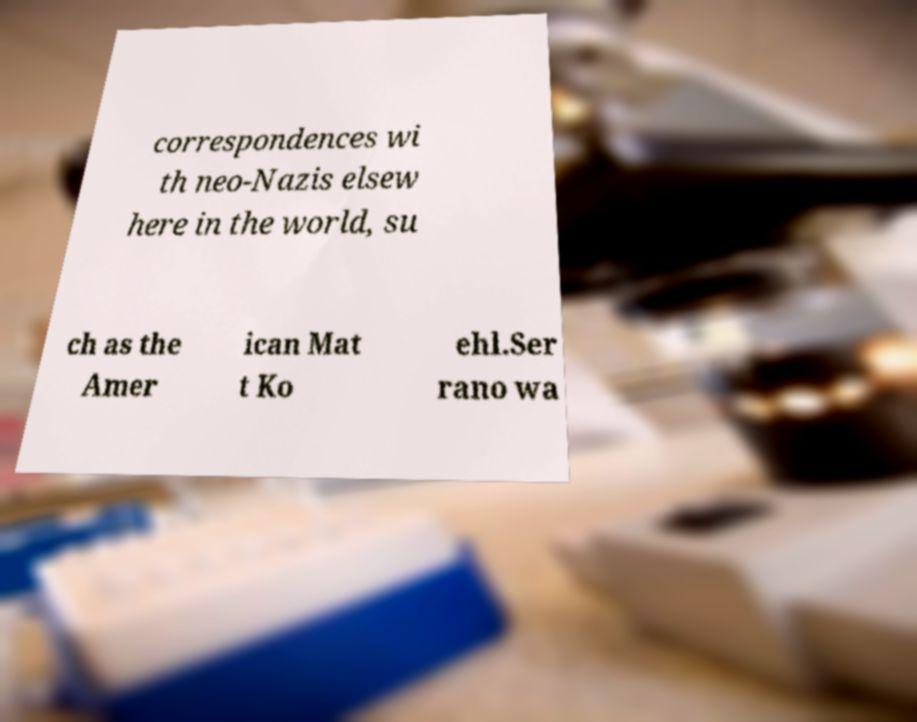I need the written content from this picture converted into text. Can you do that? correspondences wi th neo-Nazis elsew here in the world, su ch as the Amer ican Mat t Ko ehl.Ser rano wa 